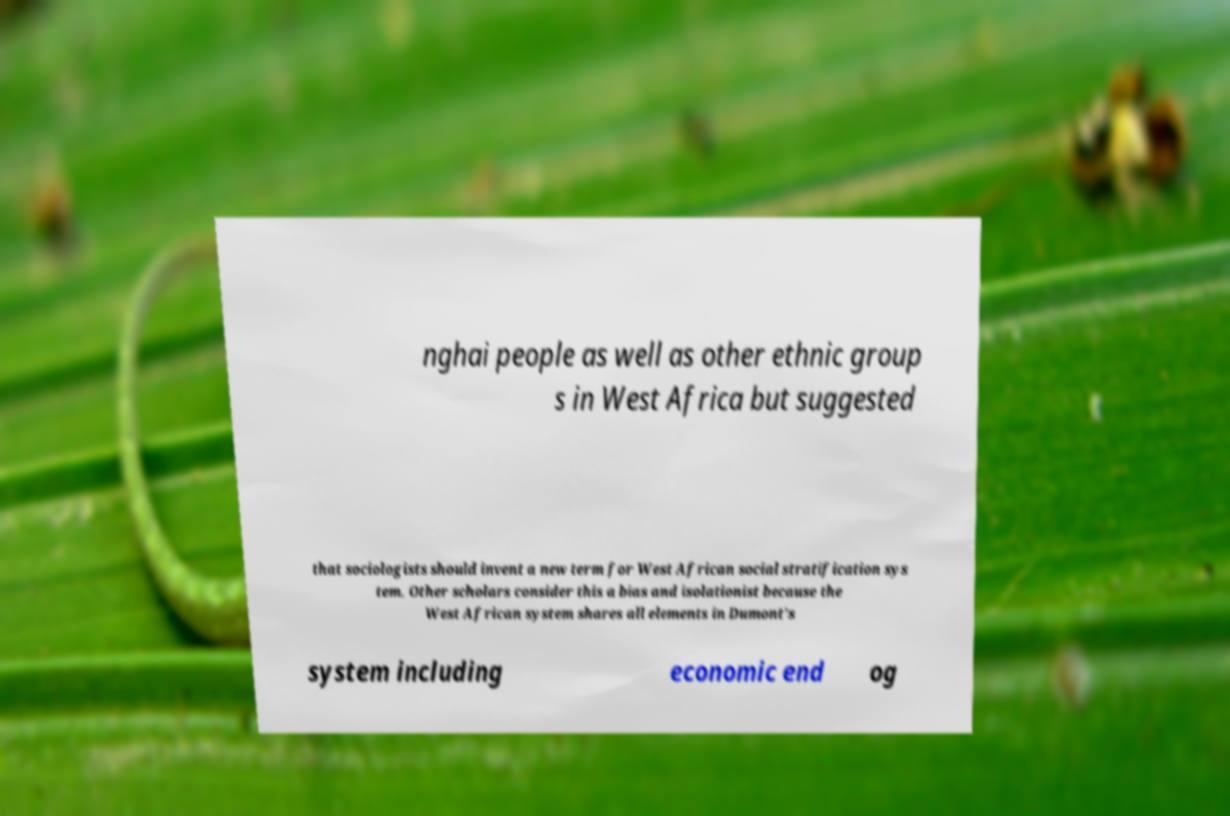Could you extract and type out the text from this image? nghai people as well as other ethnic group s in West Africa but suggested that sociologists should invent a new term for West African social stratification sys tem. Other scholars consider this a bias and isolationist because the West African system shares all elements in Dumont's system including economic end og 